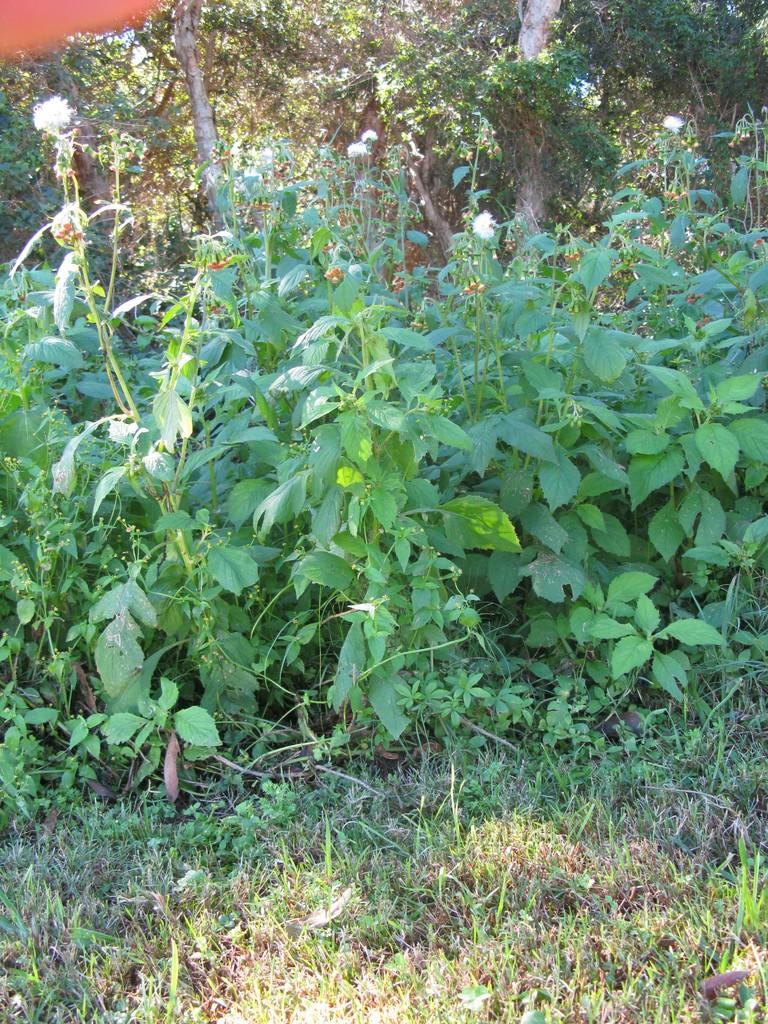What is located on the ground in the image? There is a group of plants on the ground in the image. What can be seen in the background of the image? There is a group of trees in the background of the image. What type of mask is being worn by the dress in the image? There is no mask or dress present in the image; it features a group of plants on the ground and trees in the background. 